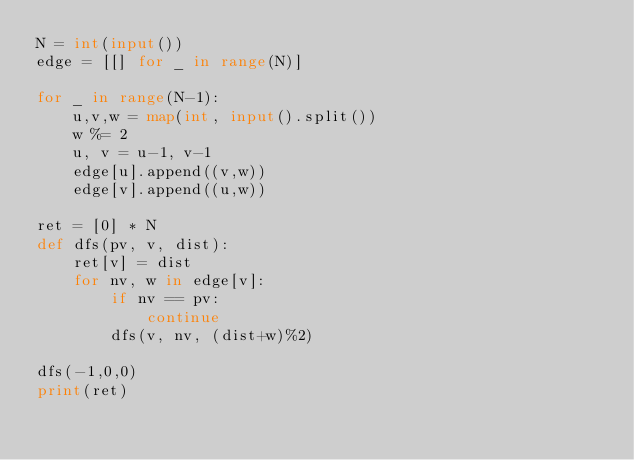Convert code to text. <code><loc_0><loc_0><loc_500><loc_500><_Python_>N = int(input())
edge = [[] for _ in range(N)]

for _ in range(N-1):
    u,v,w = map(int, input().split())
    w %= 2
    u, v = u-1, v-1
    edge[u].append((v,w))
    edge[v].append((u,w))

ret = [0] * N
def dfs(pv, v, dist):
    ret[v] = dist
    for nv, w in edge[v]:
        if nv == pv:
            continue
        dfs(v, nv, (dist+w)%2)

dfs(-1,0,0)
print(ret)
</code> 